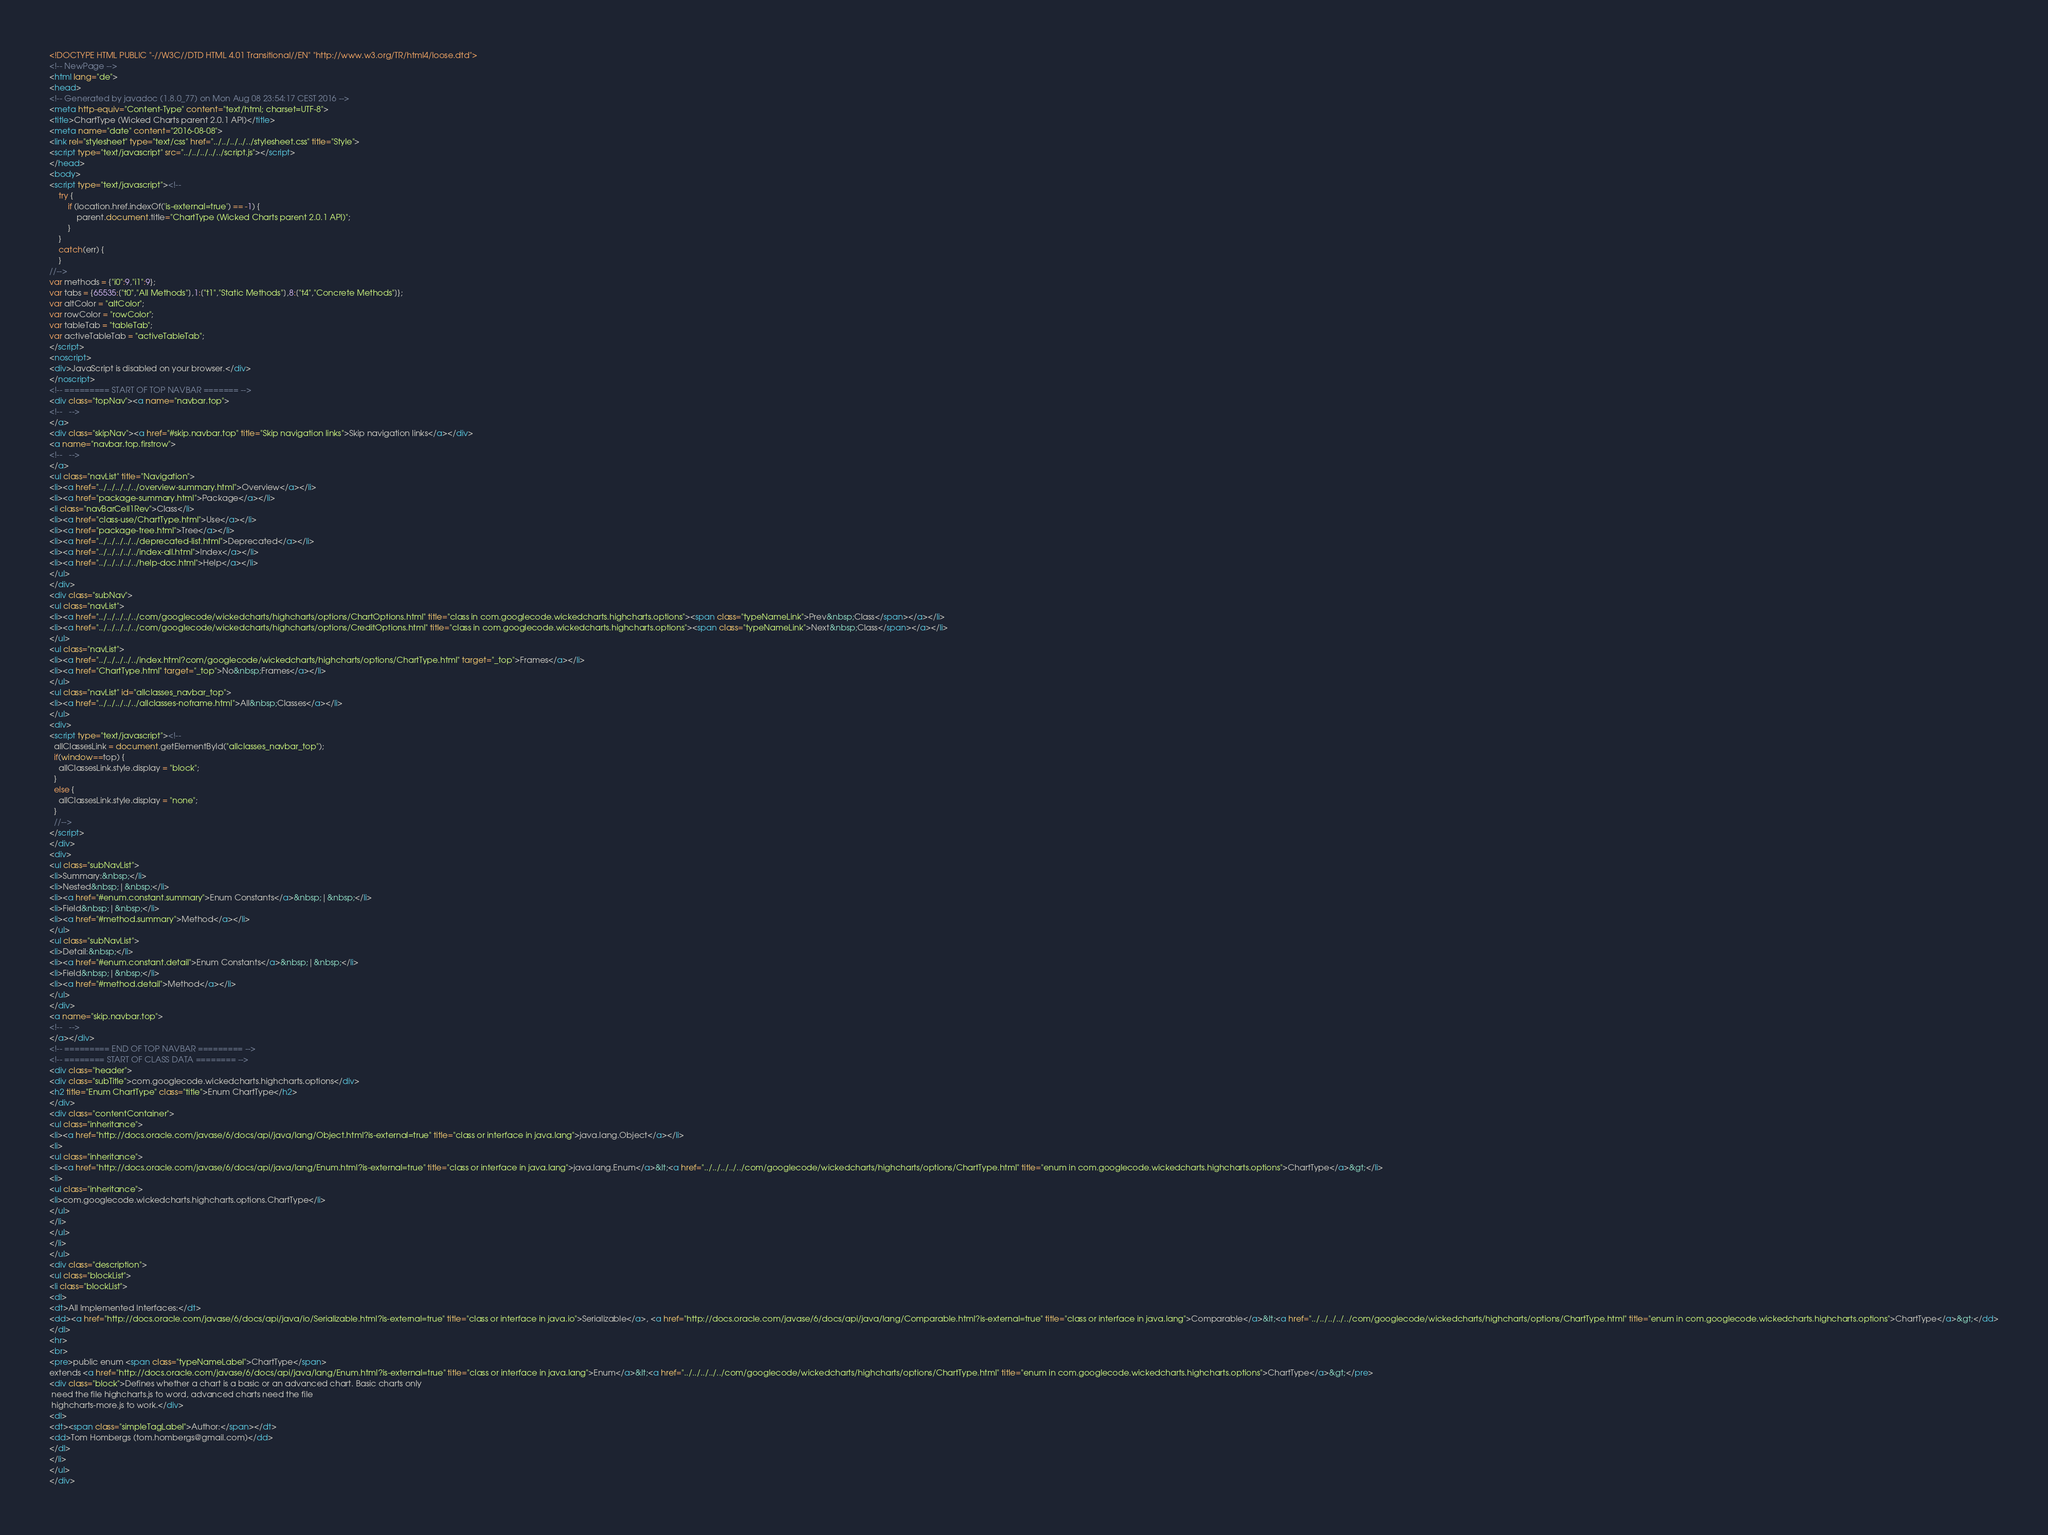<code> <loc_0><loc_0><loc_500><loc_500><_HTML_><!DOCTYPE HTML PUBLIC "-//W3C//DTD HTML 4.01 Transitional//EN" "http://www.w3.org/TR/html4/loose.dtd">
<!-- NewPage -->
<html lang="de">
<head>
<!-- Generated by javadoc (1.8.0_77) on Mon Aug 08 23:54:17 CEST 2016 -->
<meta http-equiv="Content-Type" content="text/html; charset=UTF-8">
<title>ChartType (Wicked Charts parent 2.0.1 API)</title>
<meta name="date" content="2016-08-08">
<link rel="stylesheet" type="text/css" href="../../../../../stylesheet.css" title="Style">
<script type="text/javascript" src="../../../../../script.js"></script>
</head>
<body>
<script type="text/javascript"><!--
    try {
        if (location.href.indexOf('is-external=true') == -1) {
            parent.document.title="ChartType (Wicked Charts parent 2.0.1 API)";
        }
    }
    catch(err) {
    }
//-->
var methods = {"i0":9,"i1":9};
var tabs = {65535:["t0","All Methods"],1:["t1","Static Methods"],8:["t4","Concrete Methods"]};
var altColor = "altColor";
var rowColor = "rowColor";
var tableTab = "tableTab";
var activeTableTab = "activeTableTab";
</script>
<noscript>
<div>JavaScript is disabled on your browser.</div>
</noscript>
<!-- ========= START OF TOP NAVBAR ======= -->
<div class="topNav"><a name="navbar.top">
<!--   -->
</a>
<div class="skipNav"><a href="#skip.navbar.top" title="Skip navigation links">Skip navigation links</a></div>
<a name="navbar.top.firstrow">
<!--   -->
</a>
<ul class="navList" title="Navigation">
<li><a href="../../../../../overview-summary.html">Overview</a></li>
<li><a href="package-summary.html">Package</a></li>
<li class="navBarCell1Rev">Class</li>
<li><a href="class-use/ChartType.html">Use</a></li>
<li><a href="package-tree.html">Tree</a></li>
<li><a href="../../../../../deprecated-list.html">Deprecated</a></li>
<li><a href="../../../../../index-all.html">Index</a></li>
<li><a href="../../../../../help-doc.html">Help</a></li>
</ul>
</div>
<div class="subNav">
<ul class="navList">
<li><a href="../../../../../com/googlecode/wickedcharts/highcharts/options/ChartOptions.html" title="class in com.googlecode.wickedcharts.highcharts.options"><span class="typeNameLink">Prev&nbsp;Class</span></a></li>
<li><a href="../../../../../com/googlecode/wickedcharts/highcharts/options/CreditOptions.html" title="class in com.googlecode.wickedcharts.highcharts.options"><span class="typeNameLink">Next&nbsp;Class</span></a></li>
</ul>
<ul class="navList">
<li><a href="../../../../../index.html?com/googlecode/wickedcharts/highcharts/options/ChartType.html" target="_top">Frames</a></li>
<li><a href="ChartType.html" target="_top">No&nbsp;Frames</a></li>
</ul>
<ul class="navList" id="allclasses_navbar_top">
<li><a href="../../../../../allclasses-noframe.html">All&nbsp;Classes</a></li>
</ul>
<div>
<script type="text/javascript"><!--
  allClassesLink = document.getElementById("allclasses_navbar_top");
  if(window==top) {
    allClassesLink.style.display = "block";
  }
  else {
    allClassesLink.style.display = "none";
  }
  //-->
</script>
</div>
<div>
<ul class="subNavList">
<li>Summary:&nbsp;</li>
<li>Nested&nbsp;|&nbsp;</li>
<li><a href="#enum.constant.summary">Enum Constants</a>&nbsp;|&nbsp;</li>
<li>Field&nbsp;|&nbsp;</li>
<li><a href="#method.summary">Method</a></li>
</ul>
<ul class="subNavList">
<li>Detail:&nbsp;</li>
<li><a href="#enum.constant.detail">Enum Constants</a>&nbsp;|&nbsp;</li>
<li>Field&nbsp;|&nbsp;</li>
<li><a href="#method.detail">Method</a></li>
</ul>
</div>
<a name="skip.navbar.top">
<!--   -->
</a></div>
<!-- ========= END OF TOP NAVBAR ========= -->
<!-- ======== START OF CLASS DATA ======== -->
<div class="header">
<div class="subTitle">com.googlecode.wickedcharts.highcharts.options</div>
<h2 title="Enum ChartType" class="title">Enum ChartType</h2>
</div>
<div class="contentContainer">
<ul class="inheritance">
<li><a href="http://docs.oracle.com/javase/6/docs/api/java/lang/Object.html?is-external=true" title="class or interface in java.lang">java.lang.Object</a></li>
<li>
<ul class="inheritance">
<li><a href="http://docs.oracle.com/javase/6/docs/api/java/lang/Enum.html?is-external=true" title="class or interface in java.lang">java.lang.Enum</a>&lt;<a href="../../../../../com/googlecode/wickedcharts/highcharts/options/ChartType.html" title="enum in com.googlecode.wickedcharts.highcharts.options">ChartType</a>&gt;</li>
<li>
<ul class="inheritance">
<li>com.googlecode.wickedcharts.highcharts.options.ChartType</li>
</ul>
</li>
</ul>
</li>
</ul>
<div class="description">
<ul class="blockList">
<li class="blockList">
<dl>
<dt>All Implemented Interfaces:</dt>
<dd><a href="http://docs.oracle.com/javase/6/docs/api/java/io/Serializable.html?is-external=true" title="class or interface in java.io">Serializable</a>, <a href="http://docs.oracle.com/javase/6/docs/api/java/lang/Comparable.html?is-external=true" title="class or interface in java.lang">Comparable</a>&lt;<a href="../../../../../com/googlecode/wickedcharts/highcharts/options/ChartType.html" title="enum in com.googlecode.wickedcharts.highcharts.options">ChartType</a>&gt;</dd>
</dl>
<hr>
<br>
<pre>public enum <span class="typeNameLabel">ChartType</span>
extends <a href="http://docs.oracle.com/javase/6/docs/api/java/lang/Enum.html?is-external=true" title="class or interface in java.lang">Enum</a>&lt;<a href="../../../../../com/googlecode/wickedcharts/highcharts/options/ChartType.html" title="enum in com.googlecode.wickedcharts.highcharts.options">ChartType</a>&gt;</pre>
<div class="block">Defines whether a chart is a basic or an advanced chart. Basic charts only
 need the file highcharts.js to word, advanced charts need the file
 highcharts-more.js to work.</div>
<dl>
<dt><span class="simpleTagLabel">Author:</span></dt>
<dd>Tom Hombergs (tom.hombergs@gmail.com)</dd>
</dl>
</li>
</ul>
</div></code> 